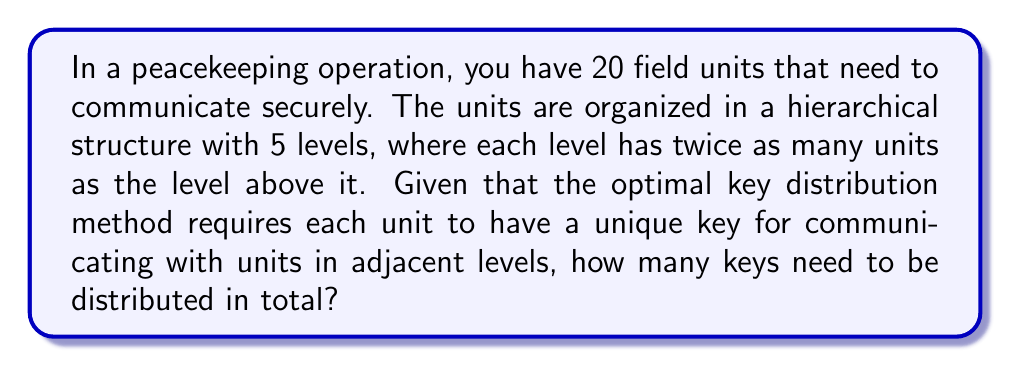Teach me how to tackle this problem. Let's approach this step-by-step:

1) First, we need to determine the number of units at each level:
   Level 1 (top): $1$ unit
   Level 2: $2$ units
   Level 3: $4$ units
   Level 4: $8$ units
   Level 5 (bottom): $5$ units (to make the total 20)

2) Now, we need to calculate the number of keys for each level:

   a) Level 1 needs keys to communicate with Level 2:
      $1 \times 2 = 2$ keys

   b) Level 2 needs keys to communicate with Level 1 and Level 3:
      $2 \times 1 + 2 \times 4 = 10$ keys

   c) Level 3 needs keys to communicate with Level 2 and Level 4:
      $4 \times 2 + 4 \times 8 = 40$ keys

   d) Level 4 needs keys to communicate with Level 3 and Level 5:
      $8 \times 4 + 8 \times 5 = 72$ keys

   e) Level 5 needs keys to communicate with Level 4:
      $5 \times 8 = 40$ keys

3) The total number of keys is the sum of all these:

   $$2 + 10 + 40 + 72 + 40 = 164$$

Therefore, 164 keys need to be distributed in total.
Answer: 164 keys 